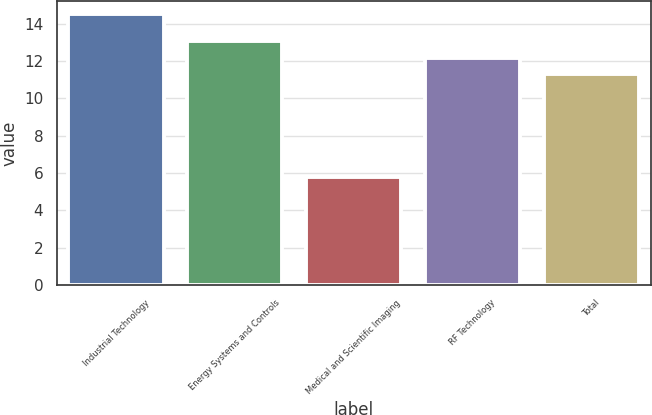Convert chart. <chart><loc_0><loc_0><loc_500><loc_500><bar_chart><fcel>Industrial Technology<fcel>Energy Systems and Controls<fcel>Medical and Scientific Imaging<fcel>RF Technology<fcel>Total<nl><fcel>14.5<fcel>13.04<fcel>5.8<fcel>12.17<fcel>11.3<nl></chart> 